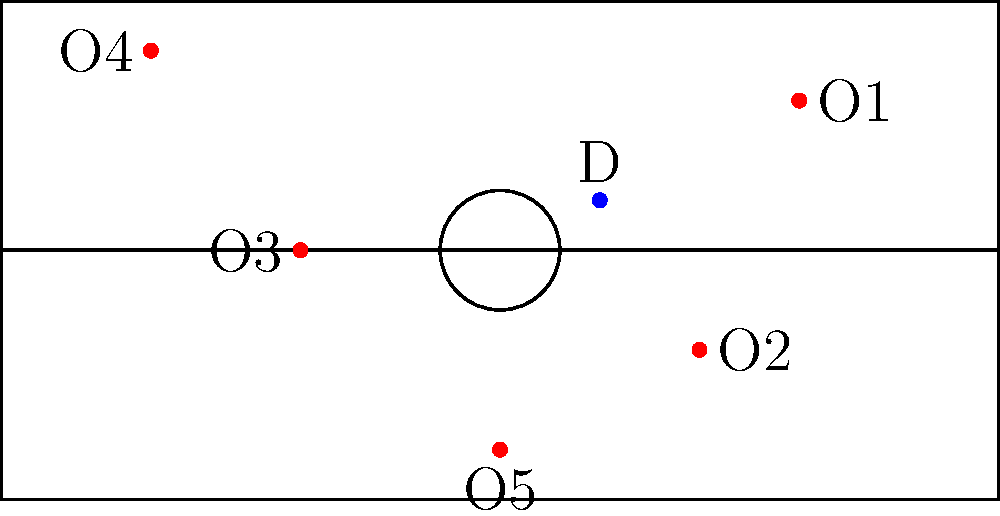As the defensive player (D) in the diagram, where should you position yourself to best defend against the offensive players (O1-O5) shown on the court? To determine the best defensive positioning, we need to consider several factors:

1. Proximity to the basket: The defensive player should prioritize protecting the area closest to the basket.

2. Ball position: The defensive player should be aware of which offensive player has the ball (or is most likely to receive it).

3. Help defense: The defender should be in a position to provide help to teammates if needed.

4. Passing lanes: The defender should try to disrupt potential passing lanes between offensive players.

Given the offensive players' positions:

1. O1 (30,15) and O2 (20,-10) are on the right side of the court.
2. O3 (-20,0) is near the top of the key.
3. O4 (-35,20) is in the left corner.
4. O5 (0,-20) is near the baseline under the basket.

The best position for the defensive player (D) would be around (5,-5). This position allows the defender to:

1. Stay close to the basket to protect against drives or cuts from O5.
2. Be in a help position for teammates guarding O1 and O2 on the right side.
3. Disrupt passing lanes between O3 and O5.
4. Quickly rotate to help on O4 if needed.

This position embodies the principle of "one foot in the paint," allowing the defender to see all offensive players and react quickly to any offensive movements.
Answer: Near (5,-5) on the court 